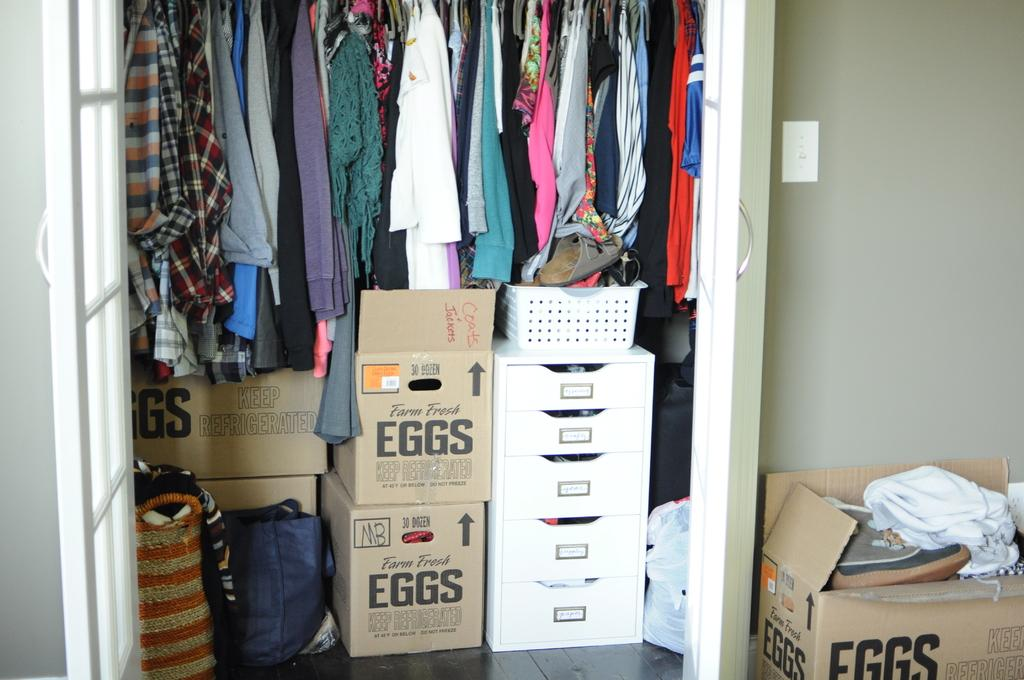What can be found inside the wardrobe in the image? There are clothes and many boxes inside the wardrobe. Are there any other objects near the wardrobe? Yes, there is another box beside the wardrobe. What is visible in the background of the image? There is a wall in the background. What language is spoken by the coal in the image? There is no coal present in the image, so it is not possible to determine what language might be spoken by any coal. 